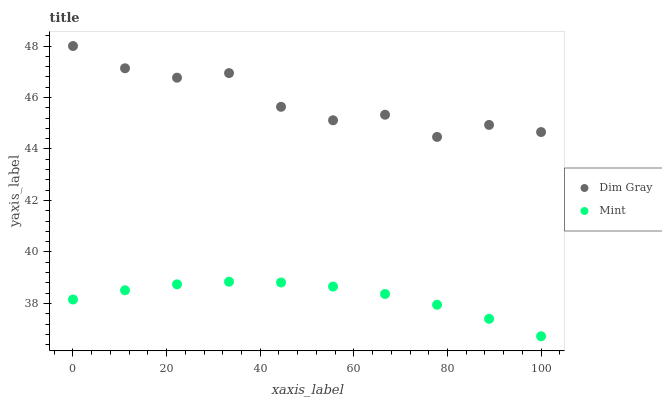Does Mint have the minimum area under the curve?
Answer yes or no. Yes. Does Dim Gray have the maximum area under the curve?
Answer yes or no. Yes. Does Mint have the maximum area under the curve?
Answer yes or no. No. Is Mint the smoothest?
Answer yes or no. Yes. Is Dim Gray the roughest?
Answer yes or no. Yes. Is Mint the roughest?
Answer yes or no. No. Does Mint have the lowest value?
Answer yes or no. Yes. Does Dim Gray have the highest value?
Answer yes or no. Yes. Does Mint have the highest value?
Answer yes or no. No. Is Mint less than Dim Gray?
Answer yes or no. Yes. Is Dim Gray greater than Mint?
Answer yes or no. Yes. Does Mint intersect Dim Gray?
Answer yes or no. No. 